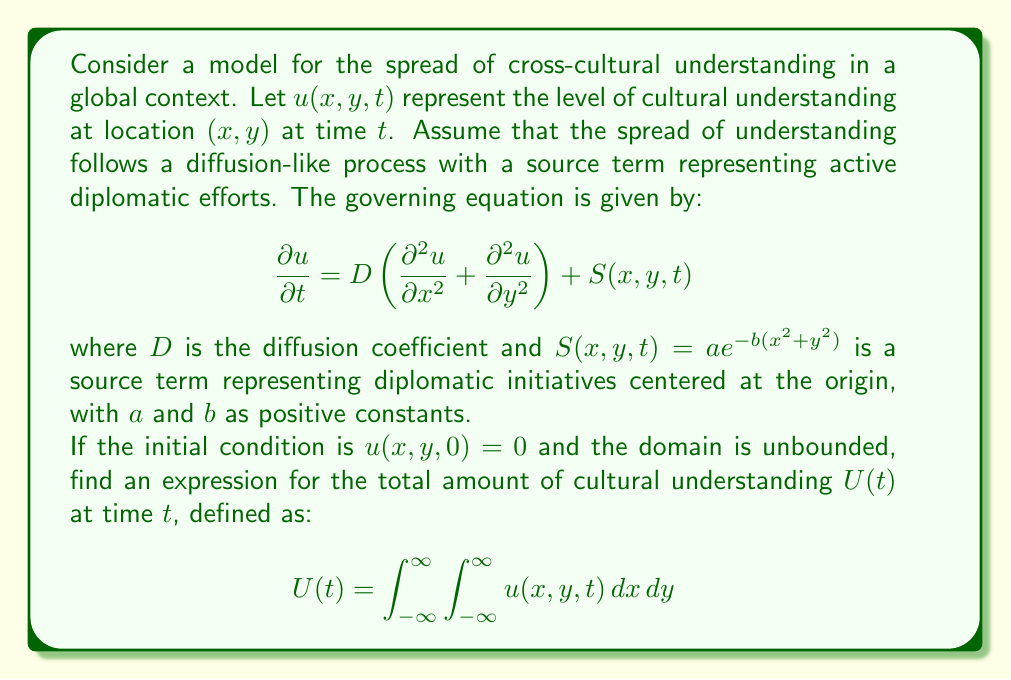Show me your answer to this math problem. To solve this problem, we'll follow these steps:

1) First, we need to find the solution for $u(x,y,t)$. The general solution for a diffusion equation with a source term is given by the convolution of the Green's function with the source term:

   $$u(x,y,t) = \int_0^t \int_{-\infty}^{\infty}\int_{-\infty}^{\infty} G(x-x',y-y',t-t') S(x',y',t') \, dx' \, dy' \, dt'$$

   where $G(x,y,t) = \frac{1}{4\pi Dt}e^{-\frac{x^2+y^2}{4Dt}}$ is the Green's function for the 2D diffusion equation.

2) Substituting our source term:

   $$u(x,y,t) = \int_0^t \int_{-\infty}^{\infty}\int_{-\infty}^{\infty} \frac{1}{4\pi D(t-t')}e^{-\frac{(x-x')^2+(y-y')^2}{4D(t-t')}} ae^{-b(x'^2+y'^2)} \, dx' \, dy' \, dt'$$

3) To find $U(t)$, we need to integrate $u(x,y,t)$ over all space:

   $$U(t) = \int_{-\infty}^{\infty}\int_{-\infty}^{\infty} u(x,y,t) \, dx \, dy$$

4) Interchanging the order of integration:

   $$U(t) = \int_0^t \int_{-\infty}^{\infty}\int_{-\infty}^{\infty} \int_{-\infty}^{\infty}\int_{-\infty}^{\infty} \frac{a}{4\pi D(t-t')}e^{-\frac{(x-x')^2+(y-y')^2}{4D(t-t')}} e^{-b(x'^2+y'^2)} \, dx \, dy \, dx' \, dy' \, dt'$$

5) The inner double integral over $x$ and $y$ equals 1 due to the properties of the Green's function. This simplifies our equation to:

   $$U(t) = \int_0^t \int_{-\infty}^{\infty}\int_{-\infty}^{\infty} ae^{-b(x'^2+y'^2)} \, dx' \, dy' \, dt'$$

6) The double integral over $x'$ and $y'$ can be evaluated:

   $$\int_{-\infty}^{\infty}\int_{-\infty}^{\infty} ae^{-b(x'^2+y'^2)} \, dx' \, dy' = \frac{\pi a}{b}$$

7) Our equation now becomes:

   $$U(t) = \int_0^t \frac{\pi a}{b} \, dt' = \frac{\pi a}{b}t$$

Thus, we have found an expression for $U(t)$.
Answer: $$U(t) = \frac{\pi a}{b}t$$ 